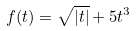Convert formula to latex. <formula><loc_0><loc_0><loc_500><loc_500>f ( t ) = \sqrt { | t | } + 5 t ^ { 3 }</formula> 